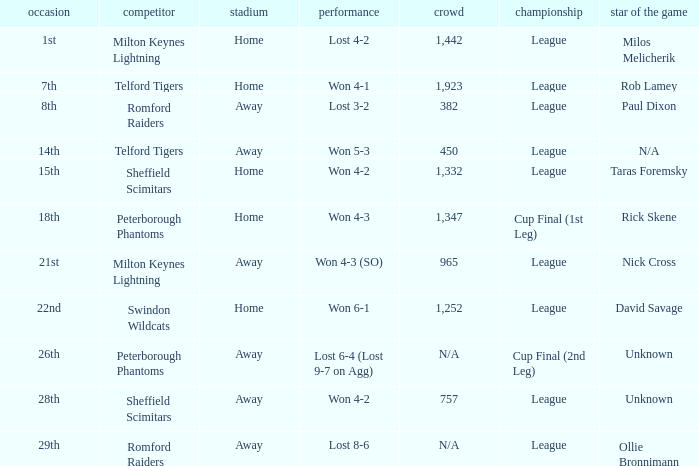What was the date when the opponent was Sheffield Scimitars and the venue was Home? 15th. 